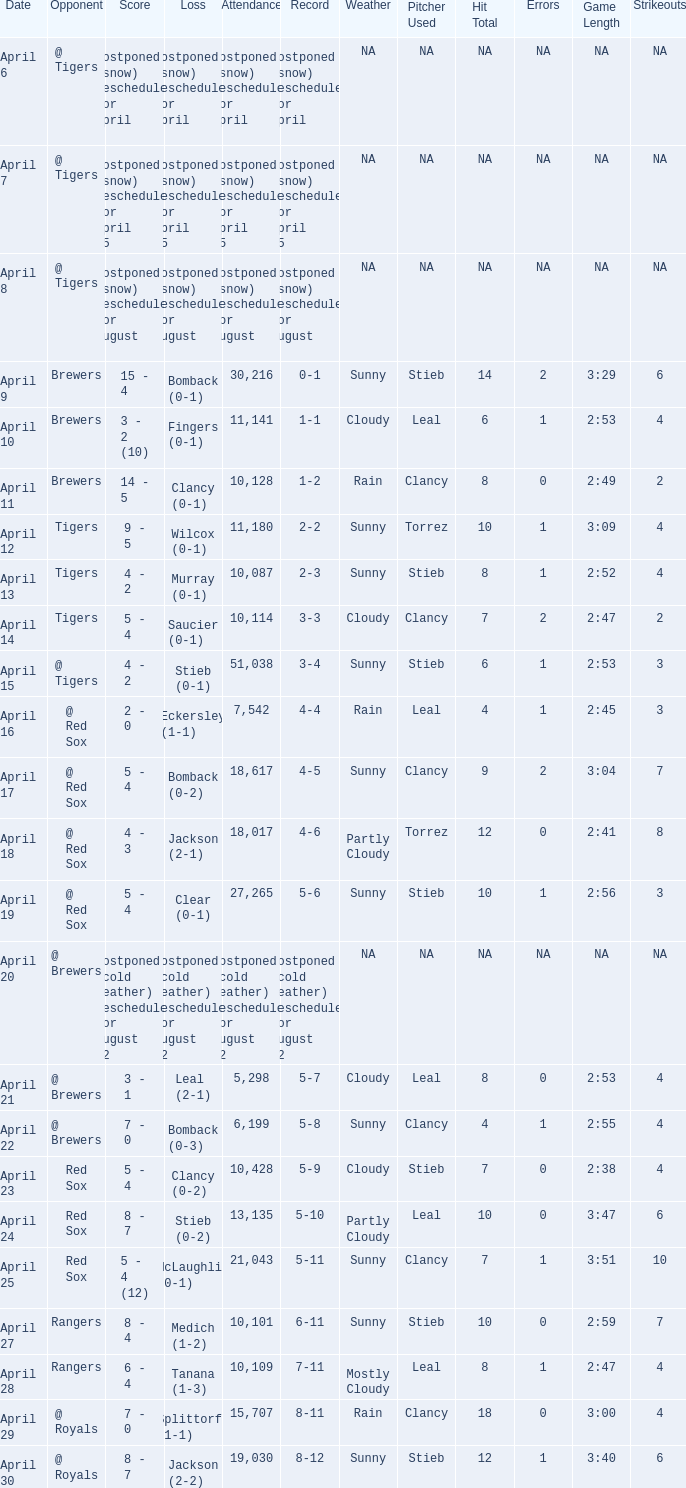What was the date for the game that had an attendance of 10,101? April 27. 